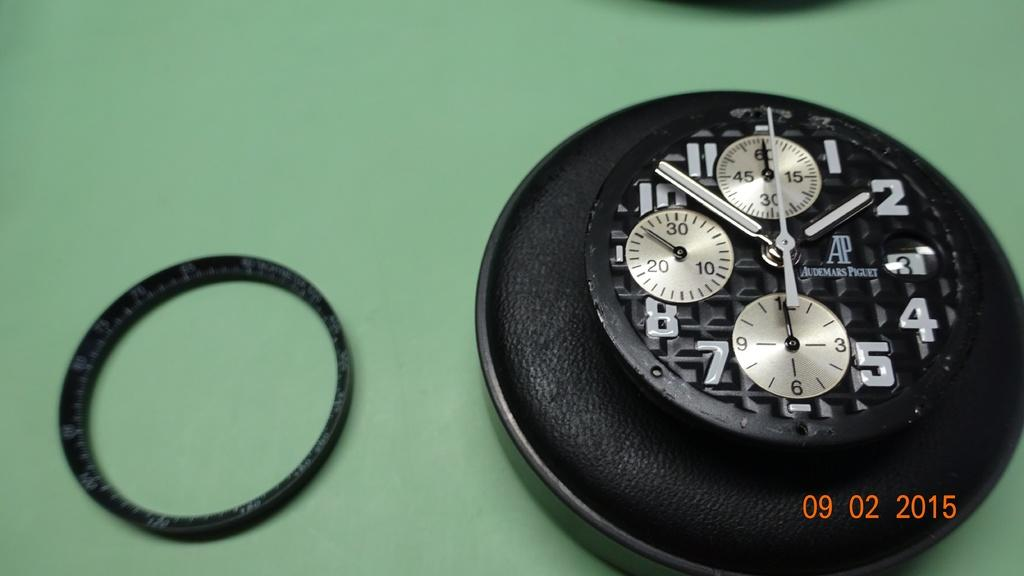<image>
Offer a succinct explanation of the picture presented. A photo taken on September 2, 2015 shows the face of a watch on a green background. 